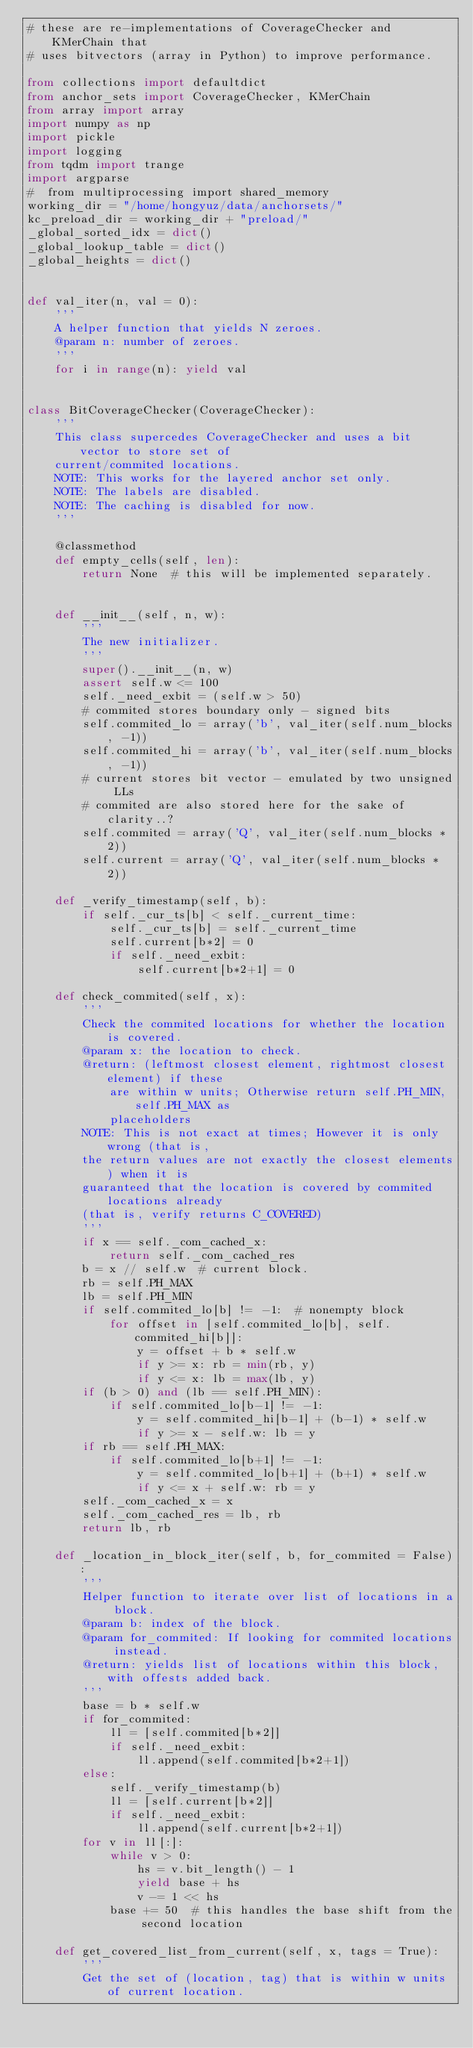Convert code to text. <code><loc_0><loc_0><loc_500><loc_500><_Python_># these are re-implementations of CoverageChecker and KMerChain that
# uses bitvectors (array in Python) to improve performance.

from collections import defaultdict
from anchor_sets import CoverageChecker, KMerChain
from array import array
import numpy as np
import pickle
import logging
from tqdm import trange
import argparse
#  from multiprocessing import shared_memory
working_dir = "/home/hongyuz/data/anchorsets/"
kc_preload_dir = working_dir + "preload/"
_global_sorted_idx = dict()
_global_lookup_table = dict()
_global_heights = dict()


def val_iter(n, val = 0):
    '''
    A helper function that yields N zeroes.
    @param n: number of zeroes.
    '''
    for i in range(n): yield val


class BitCoverageChecker(CoverageChecker):
    '''
    This class supercedes CoverageChecker and uses a bit vector to store set of
    current/commited locations.
    NOTE: This works for the layered anchor set only.
    NOTE: The labels are disabled.
    NOTE: The caching is disabled for now.
    '''

    @classmethod
    def empty_cells(self, len):
        return None  # this will be implemented separately.


    def __init__(self, n, w):
        '''
        The new initializer.
        '''
        super().__init__(n, w)
        assert self.w <= 100
        self._need_exbit = (self.w > 50)
        # commited stores boundary only - signed bits
        self.commited_lo = array('b', val_iter(self.num_blocks, -1))
        self.commited_hi = array('b', val_iter(self.num_blocks, -1))
        # current stores bit vector - emulated by two unsigned LLs
        # commited are also stored here for the sake of clarity..?
        self.commited = array('Q', val_iter(self.num_blocks * 2))
        self.current = array('Q', val_iter(self.num_blocks * 2))

    def _verify_timestamp(self, b):
        if self._cur_ts[b] < self._current_time:
            self._cur_ts[b] = self._current_time
            self.current[b*2] = 0
            if self._need_exbit:
                self.current[b*2+1] = 0

    def check_commited(self, x):
        '''
        Check the commited locations for whether the location is covered.
        @param x: the location to check.
        @return: (leftmost closest element, rightmost closest element) if these
            are within w units; Otherwise return self.PH_MIN, self.PH_MAX as
            placeholders
        NOTE: This is not exact at times; However it is only wrong (that is,
        the return values are not exactly the closest elements) when it is
        guaranteed that the location is covered by commited locations already
        (that is, verify returns C_COVERED)
        '''
        if x == self._com_cached_x:
            return self._com_cached_res
        b = x // self.w  # current block.
        rb = self.PH_MAX
        lb = self.PH_MIN
        if self.commited_lo[b] != -1:  # nonempty block
            for offset in [self.commited_lo[b], self.commited_hi[b]]:
                y = offset + b * self.w
                if y >= x: rb = min(rb, y)
                if y <= x: lb = max(lb, y)
        if (b > 0) and (lb == self.PH_MIN):
            if self.commited_lo[b-1] != -1:
                y = self.commited_hi[b-1] + (b-1) * self.w
                if y >= x - self.w: lb = y
        if rb == self.PH_MAX:
            if self.commited_lo[b+1] != -1:
                y = self.commited_lo[b+1] + (b+1) * self.w
                if y <= x + self.w: rb = y
        self._com_cached_x = x
        self._com_cached_res = lb, rb
        return lb, rb

    def _location_in_block_iter(self, b, for_commited = False):
        '''
        Helper function to iterate over list of locations in a block.
        @param b: index of the block.
        @param for_commited: If looking for commited locations instead.
        @return: yields list of locations within this block, with offests added back.
        '''
        base = b * self.w
        if for_commited:
            ll = [self.commited[b*2]]
            if self._need_exbit:
                ll.append(self.commited[b*2+1])
        else:
            self._verify_timestamp(b)
            ll = [self.current[b*2]]
            if self._need_exbit:
                ll.append(self.current[b*2+1])
        for v in ll[:]:
            while v > 0:
                hs = v.bit_length() - 1
                yield base + hs
                v -= 1 << hs
            base += 50  # this handles the base shift from the second location

    def get_covered_list_from_current(self, x, tags = True):
        '''
        Get the set of (location, tag) that is within w units of current location.</code> 